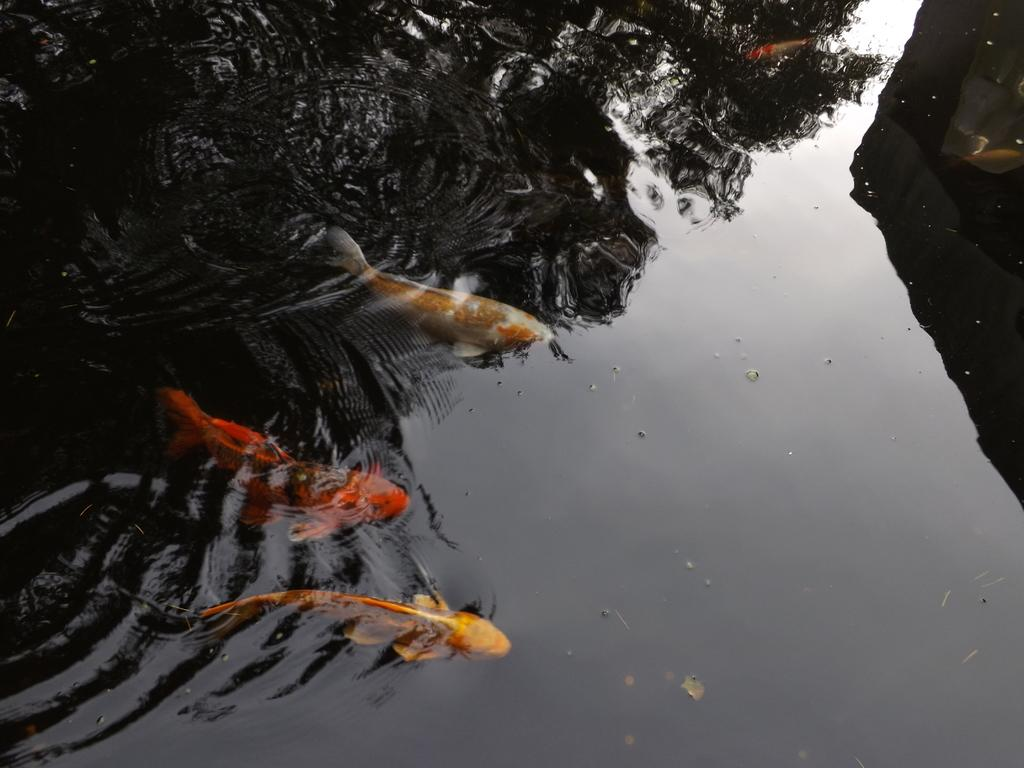What is the primary element in the picture? There is water in the picture. Can you describe the fish in the image? There are three fishes with different colors towards the left side of the picture, and another fish in orange color on the top of the picture. What type of beast can be seen near the fish in the image? There is no beast present in the image; it features only fish in the water. Can you describe the growth of the fish in the image? The fish in the image are already fully grown and do not show any growth in the picture. 